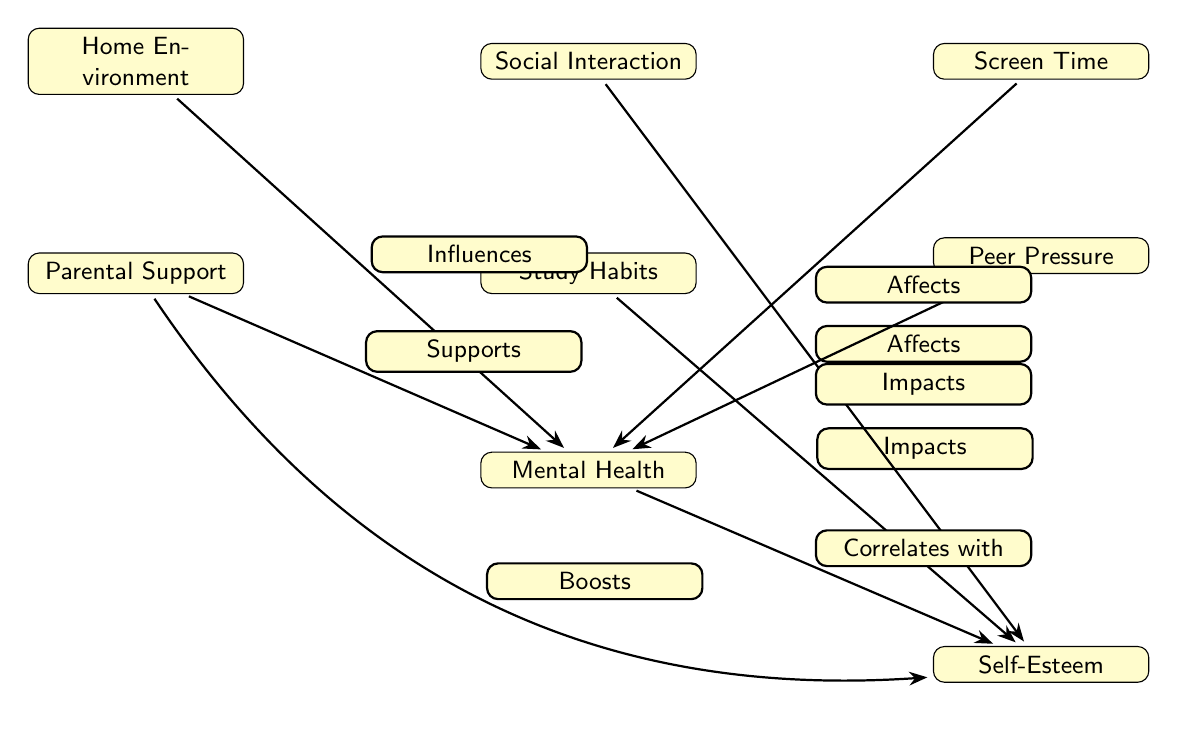What are the nodes in the diagram? The nodes of the diagram are "Home Environment," "Parental Support," "Study Habits," "Social Interaction," "Peer Pressure," "Screen Time," "Mental Health," and "Self-Esteem." Each of these is placed in the diagram as a separate entity representing different factors related to teenage depression.
Answer: Home Environment, Parental Support, Study Habits, Social Interaction, Peer Pressure, Screen Time, Mental Health, Self-Esteem How many edges are there in the diagram? The diagram contains 7 edges, which represent the relationships and influences among the various nodes. By counting the arrows that connect the nodes, we arrive at the total.
Answer: 7 What influence does "Parental Support" have on "Mental Health"? "Parental Support" has a "Supports" influence on "Mental Health," indicating that parental support positively contributes to a teenager's mental health. The edge labeled "Supports" directly connects these two nodes.
Answer: Supports What does "Study Habits" impact according to the diagram? "Study Habits" impacts "Self-Esteem," as indicated by the edge labeled "Impacts" connecting these two nodes in the diagram. This shows a direct relationship where study habits can affect self-esteem levels in teenagers.
Answer: Self-Esteem Which two nodes are directly connected by the edge labeled "Correlates with"? The edge labeled "Correlates with" connects "Mental Health" and "Self-Esteem," indicating a relationship between these two factors where changes in one may relate to changes in the other. Thus, "Mental Health" correlates with "Self-Esteem."
Answer: Mental Health, Self-Esteem What is the effect of "Screen Time" on "Mental Health"? "Screen Time" affects "Mental Health," as denoted by the edge labeled "Affects" that connects these two nodes, suggesting that excessive screen time could have negative implications for mental health in teenagers.
Answer: Affects Which node boosts "Self-Esteem"? The node that boosts "Self-Esteem" is "Parental Support," as indicated by the edge labeled "Boosts." This suggests a positive role that parental involvement or support plays in enhancing a teenager's self-esteem.
Answer: Parental Support What is the relationship between "Peer Pressure" and "Mental Health"? "Peer Pressure" impacts "Mental Health," as indicated by the edge labeled "Impacts." This signifies that peer pressure may have a significant influence on the mental health status of teenagers.
Answer: Impacts 